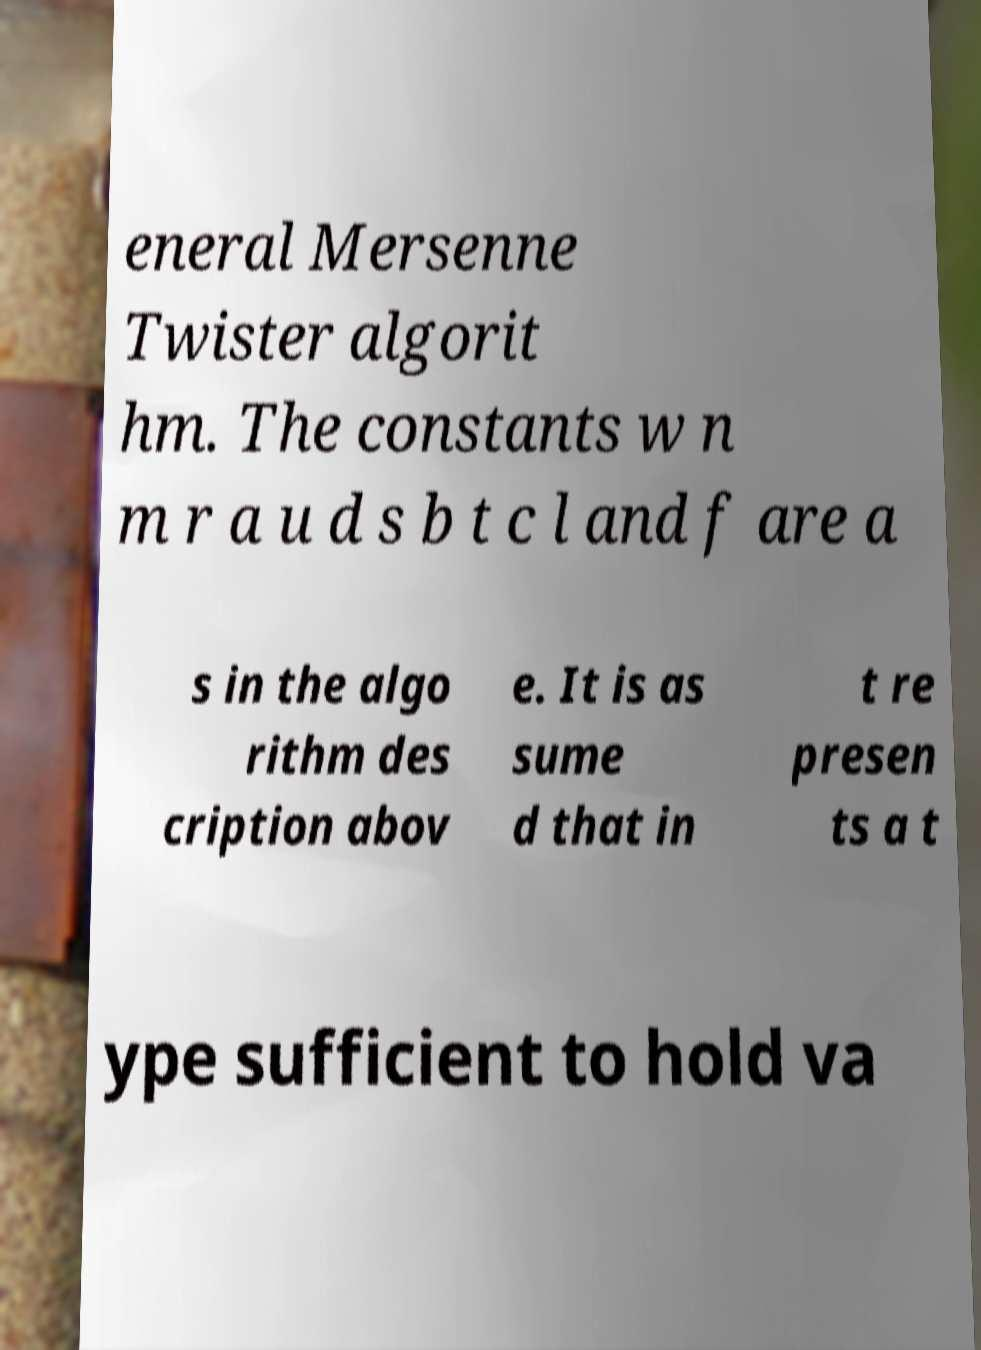Can you read and provide the text displayed in the image?This photo seems to have some interesting text. Can you extract and type it out for me? eneral Mersenne Twister algorit hm. The constants w n m r a u d s b t c l and f are a s in the algo rithm des cription abov e. It is as sume d that in t re presen ts a t ype sufficient to hold va 